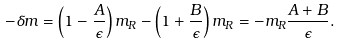Convert formula to latex. <formula><loc_0><loc_0><loc_500><loc_500>- \delta m = \left ( 1 - \frac { A } { \epsilon } \right ) m _ { R } - \left ( 1 + \frac { B } { \epsilon } \right ) m _ { R } = - m _ { R } \frac { A + B } { \epsilon } .</formula> 